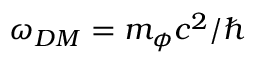Convert formula to latex. <formula><loc_0><loc_0><loc_500><loc_500>\omega _ { D M } = m _ { \phi } c ^ { 2 } / \hbar</formula> 